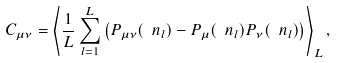Convert formula to latex. <formula><loc_0><loc_0><loc_500><loc_500>C _ { \mu \nu } = \left \langle \frac { 1 } { L } \sum _ { l = 1 } ^ { L } \left ( P _ { \mu \nu } ( \ n _ { l } ) - P _ { \mu } ( \ n _ { l } ) P _ { \nu } ( \ n _ { l } ) \right ) \right \rangle _ { L } ,</formula> 